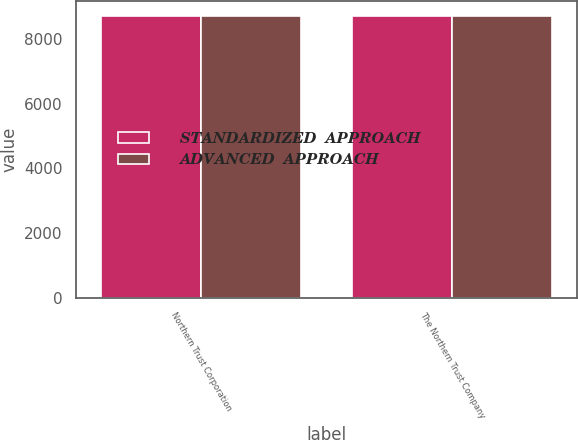<chart> <loc_0><loc_0><loc_500><loc_500><stacked_bar_chart><ecel><fcel>Northern Trust Corporation<fcel>The Northern Trust Company<nl><fcel>STANDARDIZED  APPROACH<fcel>8729.8<fcel>8722.5<nl><fcel>ADVANCED  APPROACH<fcel>8729.8<fcel>8722.5<nl></chart> 